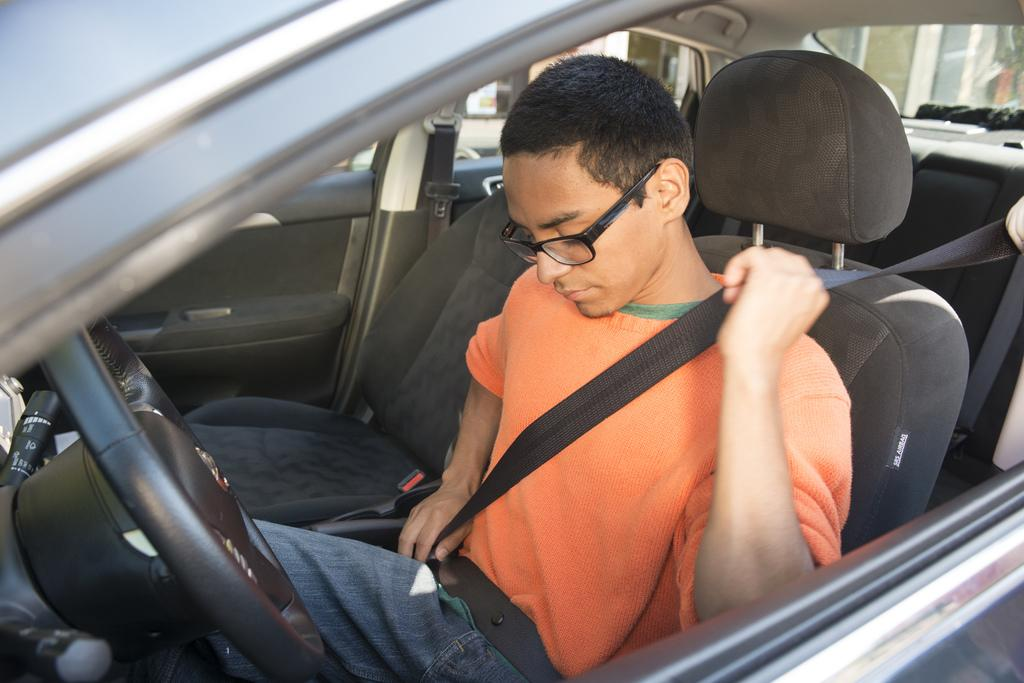Who is the main subject in the image? There is a boy in the image. What is the boy doing in the image? The boy is sitting in the driver seat of a car. What is the boy wearing in the image? The boy is wearing an orange color t-shirt and black color spectacles. What type of hose is connected to the car in the image? There is no hose connected to the car in the image. What kind of plant is growing near the car in the image? There is no plant visible in the image. 